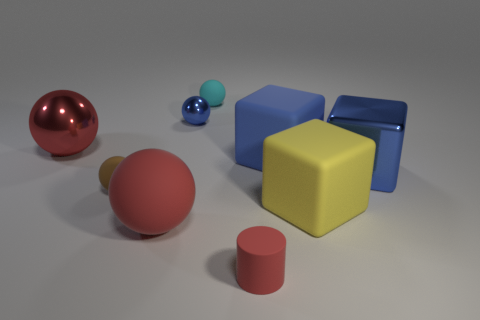What number of other things are there of the same color as the metal cube?
Your answer should be very brief. 2. There is a tiny cylinder that is the same color as the big shiny ball; what material is it?
Make the answer very short. Rubber. Does the cylinder have the same material as the brown ball?
Give a very brief answer. Yes. There is a matte object that is both behind the metal cube and in front of the cyan rubber ball; what shape is it?
Your answer should be very brief. Cube. What is the shape of the big blue thing that is the same material as the cylinder?
Ensure brevity in your answer.  Cube. Is there a large yellow matte cube?
Provide a short and direct response. Yes. There is a tiny thing behind the small blue object; are there any big yellow things behind it?
Provide a short and direct response. No. There is a tiny blue object that is the same shape as the tiny cyan thing; what material is it?
Make the answer very short. Metal. Is the number of small red matte cylinders greater than the number of large rubber cylinders?
Your answer should be compact. Yes. Is the color of the big shiny sphere the same as the big metal thing that is right of the small red cylinder?
Provide a short and direct response. No. 